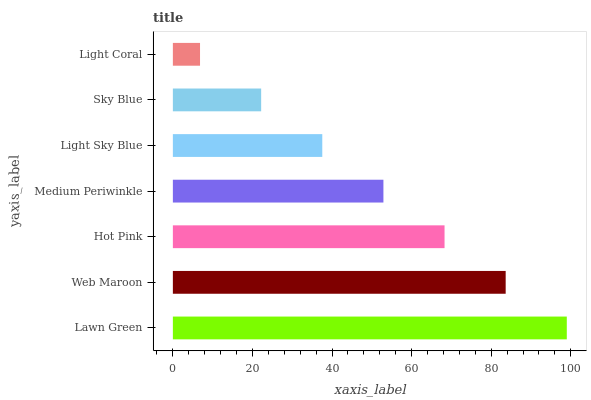Is Light Coral the minimum?
Answer yes or no. Yes. Is Lawn Green the maximum?
Answer yes or no. Yes. Is Web Maroon the minimum?
Answer yes or no. No. Is Web Maroon the maximum?
Answer yes or no. No. Is Lawn Green greater than Web Maroon?
Answer yes or no. Yes. Is Web Maroon less than Lawn Green?
Answer yes or no. Yes. Is Web Maroon greater than Lawn Green?
Answer yes or no. No. Is Lawn Green less than Web Maroon?
Answer yes or no. No. Is Medium Periwinkle the high median?
Answer yes or no. Yes. Is Medium Periwinkle the low median?
Answer yes or no. Yes. Is Web Maroon the high median?
Answer yes or no. No. Is Hot Pink the low median?
Answer yes or no. No. 